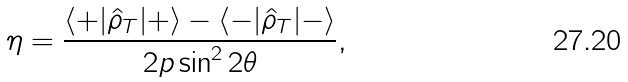Convert formula to latex. <formula><loc_0><loc_0><loc_500><loc_500>\eta = \frac { \langle + | \hat { \rho } _ { T } | + \rangle - \langle - | \hat { \rho } _ { T } | - \rangle } { 2 p \sin ^ { 2 } { 2 \theta } } ,</formula> 